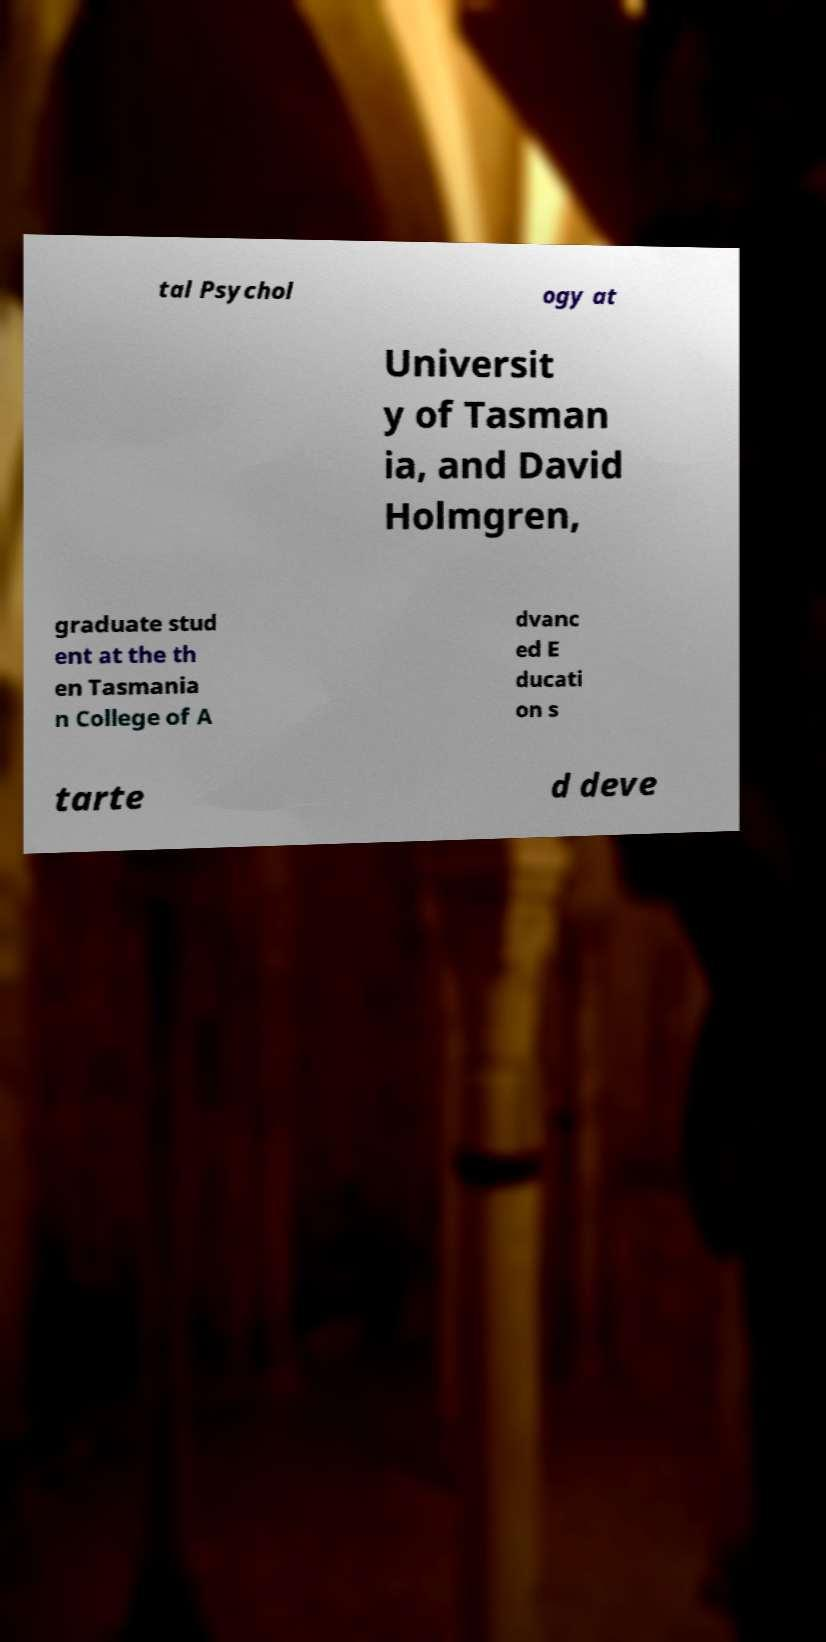For documentation purposes, I need the text within this image transcribed. Could you provide that? tal Psychol ogy at Universit y of Tasman ia, and David Holmgren, graduate stud ent at the th en Tasmania n College of A dvanc ed E ducati on s tarte d deve 